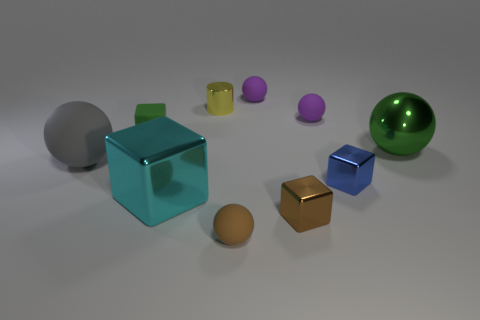What shape is the large metal object that is the same color as the tiny matte cube?
Your answer should be compact. Sphere. The object that is the same color as the shiny sphere is what size?
Make the answer very short. Small. What size is the sphere to the left of the tiny sphere that is in front of the green object that is on the left side of the tiny brown metallic cube?
Offer a terse response. Large. How many tiny objects are purple matte spheres or cylinders?
Make the answer very short. 3. Do the gray ball and the green object that is to the right of the green matte block have the same size?
Your answer should be very brief. Yes. How many other objects are the same shape as the gray thing?
Ensure brevity in your answer.  4. What is the shape of the other large object that is made of the same material as the large green thing?
Offer a very short reply. Cube. Is there a blue block?
Offer a very short reply. Yes. Is the number of small things that are on the left side of the tiny brown matte object less than the number of cubes in front of the gray sphere?
Provide a short and direct response. Yes. There is a big thing that is in front of the blue metallic block; what is its shape?
Make the answer very short. Cube. 